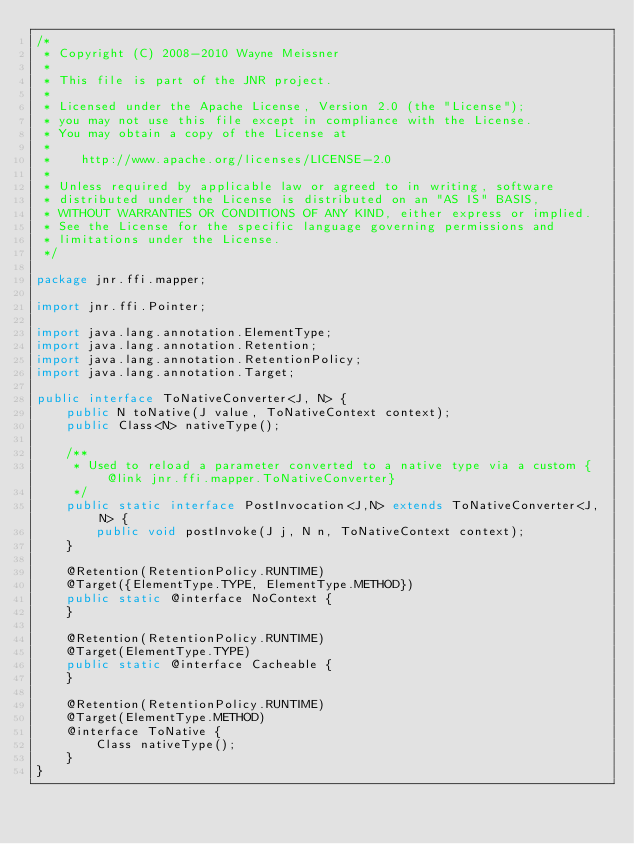<code> <loc_0><loc_0><loc_500><loc_500><_Java_>/*
 * Copyright (C) 2008-2010 Wayne Meissner
 *
 * This file is part of the JNR project.
 *
 * Licensed under the Apache License, Version 2.0 (the "License");
 * you may not use this file except in compliance with the License.
 * You may obtain a copy of the License at
 *
 *    http://www.apache.org/licenses/LICENSE-2.0
 *
 * Unless required by applicable law or agreed to in writing, software
 * distributed under the License is distributed on an "AS IS" BASIS,
 * WITHOUT WARRANTIES OR CONDITIONS OF ANY KIND, either express or implied.
 * See the License for the specific language governing permissions and
 * limitations under the License.
 */

package jnr.ffi.mapper;

import jnr.ffi.Pointer;

import java.lang.annotation.ElementType;
import java.lang.annotation.Retention;
import java.lang.annotation.RetentionPolicy;
import java.lang.annotation.Target;

public interface ToNativeConverter<J, N> {
    public N toNative(J value, ToNativeContext context);
    public Class<N> nativeType();

    /**
     * Used to reload a parameter converted to a native type via a custom {@link jnr.ffi.mapper.ToNativeConverter}
     */
    public static interface PostInvocation<J,N> extends ToNativeConverter<J, N> {
        public void postInvoke(J j, N n, ToNativeContext context);
    }

    @Retention(RetentionPolicy.RUNTIME)
    @Target({ElementType.TYPE, ElementType.METHOD})
    public static @interface NoContext {
    }

    @Retention(RetentionPolicy.RUNTIME)
    @Target(ElementType.TYPE)
    public static @interface Cacheable {
    }

    @Retention(RetentionPolicy.RUNTIME)
    @Target(ElementType.METHOD)
    @interface ToNative {
        Class nativeType();
    }
}
</code> 